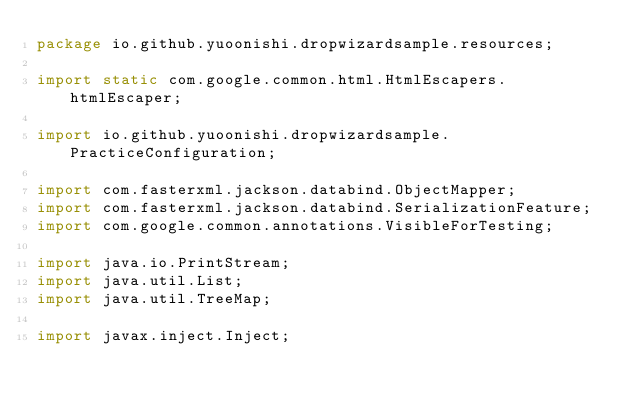Convert code to text. <code><loc_0><loc_0><loc_500><loc_500><_Java_>package io.github.yuoonishi.dropwizardsample.resources;

import static com.google.common.html.HtmlEscapers.htmlEscaper;

import io.github.yuoonishi.dropwizardsample.PracticeConfiguration;

import com.fasterxml.jackson.databind.ObjectMapper;
import com.fasterxml.jackson.databind.SerializationFeature;
import com.google.common.annotations.VisibleForTesting;

import java.io.PrintStream;
import java.util.List;
import java.util.TreeMap;

import javax.inject.Inject;</code> 